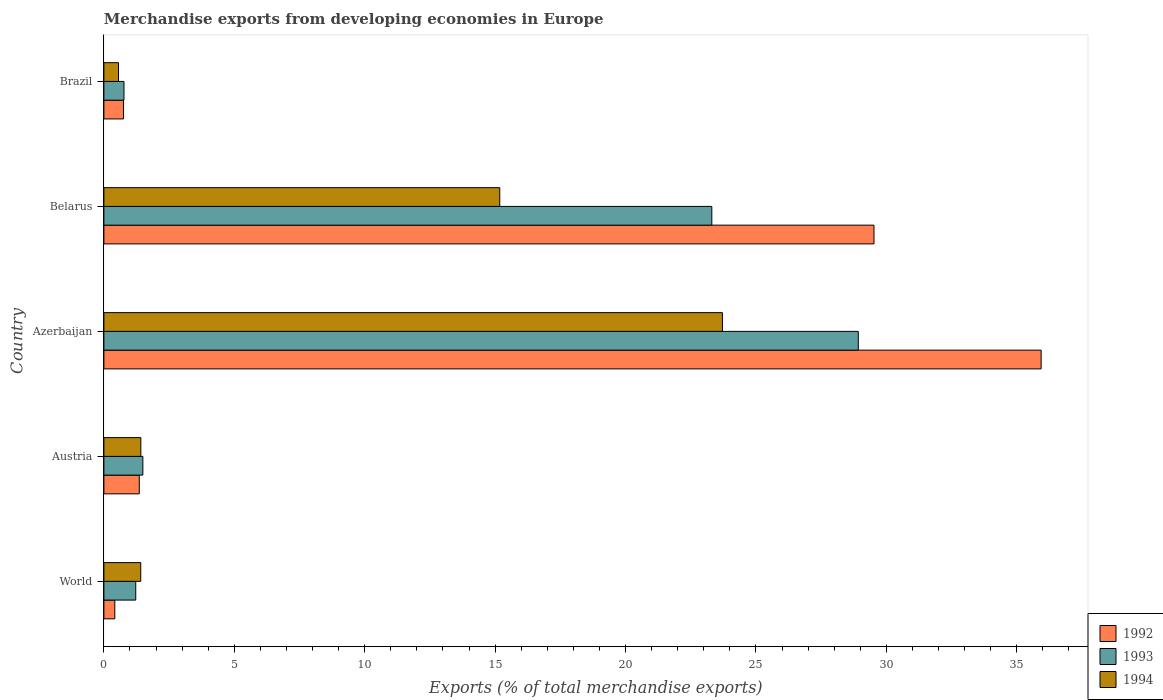How many different coloured bars are there?
Your response must be concise. 3. How many groups of bars are there?
Provide a succinct answer. 5. Are the number of bars on each tick of the Y-axis equal?
Give a very brief answer. Yes. How many bars are there on the 3rd tick from the bottom?
Offer a terse response. 3. What is the label of the 3rd group of bars from the top?
Give a very brief answer. Azerbaijan. What is the percentage of total merchandise exports in 1994 in Brazil?
Keep it short and to the point. 0.56. Across all countries, what is the maximum percentage of total merchandise exports in 1993?
Make the answer very short. 28.93. Across all countries, what is the minimum percentage of total merchandise exports in 1993?
Make the answer very short. 0.77. In which country was the percentage of total merchandise exports in 1993 maximum?
Ensure brevity in your answer.  Azerbaijan. What is the total percentage of total merchandise exports in 1994 in the graph?
Offer a very short reply. 42.29. What is the difference between the percentage of total merchandise exports in 1994 in Azerbaijan and that in Belarus?
Give a very brief answer. 8.54. What is the difference between the percentage of total merchandise exports in 1994 in Azerbaijan and the percentage of total merchandise exports in 1993 in Austria?
Offer a very short reply. 22.22. What is the average percentage of total merchandise exports in 1993 per country?
Make the answer very short. 11.14. What is the difference between the percentage of total merchandise exports in 1992 and percentage of total merchandise exports in 1993 in World?
Provide a succinct answer. -0.8. What is the ratio of the percentage of total merchandise exports in 1992 in Azerbaijan to that in Belarus?
Offer a terse response. 1.22. Is the percentage of total merchandise exports in 1993 in Brazil less than that in World?
Ensure brevity in your answer.  Yes. What is the difference between the highest and the second highest percentage of total merchandise exports in 1994?
Provide a succinct answer. 8.54. What is the difference between the highest and the lowest percentage of total merchandise exports in 1992?
Make the answer very short. 35.52. In how many countries, is the percentage of total merchandise exports in 1994 greater than the average percentage of total merchandise exports in 1994 taken over all countries?
Your answer should be compact. 2. What does the 2nd bar from the bottom in Austria represents?
Offer a terse response. 1993. Are the values on the major ticks of X-axis written in scientific E-notation?
Give a very brief answer. No. Does the graph contain any zero values?
Your answer should be compact. No. How many legend labels are there?
Give a very brief answer. 3. What is the title of the graph?
Keep it short and to the point. Merchandise exports from developing economies in Europe. What is the label or title of the X-axis?
Give a very brief answer. Exports (% of total merchandise exports). What is the Exports (% of total merchandise exports) in 1992 in World?
Keep it short and to the point. 0.42. What is the Exports (% of total merchandise exports) of 1993 in World?
Make the answer very short. 1.22. What is the Exports (% of total merchandise exports) in 1994 in World?
Ensure brevity in your answer.  1.41. What is the Exports (% of total merchandise exports) of 1992 in Austria?
Provide a succinct answer. 1.36. What is the Exports (% of total merchandise exports) of 1993 in Austria?
Keep it short and to the point. 1.49. What is the Exports (% of total merchandise exports) of 1994 in Austria?
Your answer should be compact. 1.42. What is the Exports (% of total merchandise exports) in 1992 in Azerbaijan?
Offer a terse response. 35.94. What is the Exports (% of total merchandise exports) in 1993 in Azerbaijan?
Make the answer very short. 28.93. What is the Exports (% of total merchandise exports) in 1994 in Azerbaijan?
Offer a terse response. 23.72. What is the Exports (% of total merchandise exports) in 1992 in Belarus?
Keep it short and to the point. 29.53. What is the Exports (% of total merchandise exports) of 1993 in Belarus?
Offer a terse response. 23.31. What is the Exports (% of total merchandise exports) in 1994 in Belarus?
Keep it short and to the point. 15.18. What is the Exports (% of total merchandise exports) in 1992 in Brazil?
Offer a terse response. 0.75. What is the Exports (% of total merchandise exports) in 1993 in Brazil?
Give a very brief answer. 0.77. What is the Exports (% of total merchandise exports) in 1994 in Brazil?
Make the answer very short. 0.56. Across all countries, what is the maximum Exports (% of total merchandise exports) of 1992?
Give a very brief answer. 35.94. Across all countries, what is the maximum Exports (% of total merchandise exports) of 1993?
Your response must be concise. 28.93. Across all countries, what is the maximum Exports (% of total merchandise exports) of 1994?
Ensure brevity in your answer.  23.72. Across all countries, what is the minimum Exports (% of total merchandise exports) in 1992?
Give a very brief answer. 0.42. Across all countries, what is the minimum Exports (% of total merchandise exports) in 1993?
Give a very brief answer. 0.77. Across all countries, what is the minimum Exports (% of total merchandise exports) in 1994?
Provide a succinct answer. 0.56. What is the total Exports (% of total merchandise exports) of 1992 in the graph?
Your answer should be compact. 67.99. What is the total Exports (% of total merchandise exports) in 1993 in the graph?
Provide a short and direct response. 55.72. What is the total Exports (% of total merchandise exports) of 1994 in the graph?
Your response must be concise. 42.29. What is the difference between the Exports (% of total merchandise exports) in 1992 in World and that in Austria?
Keep it short and to the point. -0.94. What is the difference between the Exports (% of total merchandise exports) of 1993 in World and that in Austria?
Your answer should be very brief. -0.27. What is the difference between the Exports (% of total merchandise exports) in 1994 in World and that in Austria?
Offer a very short reply. -0. What is the difference between the Exports (% of total merchandise exports) in 1992 in World and that in Azerbaijan?
Offer a very short reply. -35.52. What is the difference between the Exports (% of total merchandise exports) in 1993 in World and that in Azerbaijan?
Ensure brevity in your answer.  -27.7. What is the difference between the Exports (% of total merchandise exports) in 1994 in World and that in Azerbaijan?
Your response must be concise. -22.3. What is the difference between the Exports (% of total merchandise exports) in 1992 in World and that in Belarus?
Offer a very short reply. -29.11. What is the difference between the Exports (% of total merchandise exports) of 1993 in World and that in Belarus?
Make the answer very short. -22.09. What is the difference between the Exports (% of total merchandise exports) of 1994 in World and that in Belarus?
Give a very brief answer. -13.77. What is the difference between the Exports (% of total merchandise exports) in 1992 in World and that in Brazil?
Your response must be concise. -0.33. What is the difference between the Exports (% of total merchandise exports) of 1993 in World and that in Brazil?
Keep it short and to the point. 0.45. What is the difference between the Exports (% of total merchandise exports) of 1994 in World and that in Brazil?
Your answer should be very brief. 0.85. What is the difference between the Exports (% of total merchandise exports) of 1992 in Austria and that in Azerbaijan?
Your response must be concise. -34.58. What is the difference between the Exports (% of total merchandise exports) in 1993 in Austria and that in Azerbaijan?
Offer a very short reply. -27.43. What is the difference between the Exports (% of total merchandise exports) in 1994 in Austria and that in Azerbaijan?
Offer a terse response. -22.3. What is the difference between the Exports (% of total merchandise exports) in 1992 in Austria and that in Belarus?
Your answer should be very brief. -28.17. What is the difference between the Exports (% of total merchandise exports) of 1993 in Austria and that in Belarus?
Offer a terse response. -21.81. What is the difference between the Exports (% of total merchandise exports) in 1994 in Austria and that in Belarus?
Your answer should be compact. -13.76. What is the difference between the Exports (% of total merchandise exports) of 1992 in Austria and that in Brazil?
Keep it short and to the point. 0.6. What is the difference between the Exports (% of total merchandise exports) in 1993 in Austria and that in Brazil?
Give a very brief answer. 0.72. What is the difference between the Exports (% of total merchandise exports) of 1994 in Austria and that in Brazil?
Ensure brevity in your answer.  0.85. What is the difference between the Exports (% of total merchandise exports) of 1992 in Azerbaijan and that in Belarus?
Your answer should be very brief. 6.41. What is the difference between the Exports (% of total merchandise exports) of 1993 in Azerbaijan and that in Belarus?
Offer a very short reply. 5.62. What is the difference between the Exports (% of total merchandise exports) of 1994 in Azerbaijan and that in Belarus?
Your response must be concise. 8.54. What is the difference between the Exports (% of total merchandise exports) in 1992 in Azerbaijan and that in Brazil?
Provide a short and direct response. 35.18. What is the difference between the Exports (% of total merchandise exports) of 1993 in Azerbaijan and that in Brazil?
Your response must be concise. 28.16. What is the difference between the Exports (% of total merchandise exports) in 1994 in Azerbaijan and that in Brazil?
Make the answer very short. 23.15. What is the difference between the Exports (% of total merchandise exports) in 1992 in Belarus and that in Brazil?
Your answer should be very brief. 28.77. What is the difference between the Exports (% of total merchandise exports) in 1993 in Belarus and that in Brazil?
Your answer should be compact. 22.54. What is the difference between the Exports (% of total merchandise exports) of 1994 in Belarus and that in Brazil?
Make the answer very short. 14.62. What is the difference between the Exports (% of total merchandise exports) in 1992 in World and the Exports (% of total merchandise exports) in 1993 in Austria?
Your response must be concise. -1.08. What is the difference between the Exports (% of total merchandise exports) in 1992 in World and the Exports (% of total merchandise exports) in 1994 in Austria?
Provide a short and direct response. -1. What is the difference between the Exports (% of total merchandise exports) in 1993 in World and the Exports (% of total merchandise exports) in 1994 in Austria?
Ensure brevity in your answer.  -0.2. What is the difference between the Exports (% of total merchandise exports) in 1992 in World and the Exports (% of total merchandise exports) in 1993 in Azerbaijan?
Keep it short and to the point. -28.51. What is the difference between the Exports (% of total merchandise exports) in 1992 in World and the Exports (% of total merchandise exports) in 1994 in Azerbaijan?
Your answer should be very brief. -23.3. What is the difference between the Exports (% of total merchandise exports) in 1993 in World and the Exports (% of total merchandise exports) in 1994 in Azerbaijan?
Give a very brief answer. -22.49. What is the difference between the Exports (% of total merchandise exports) of 1992 in World and the Exports (% of total merchandise exports) of 1993 in Belarus?
Provide a succinct answer. -22.89. What is the difference between the Exports (% of total merchandise exports) of 1992 in World and the Exports (% of total merchandise exports) of 1994 in Belarus?
Offer a very short reply. -14.76. What is the difference between the Exports (% of total merchandise exports) in 1993 in World and the Exports (% of total merchandise exports) in 1994 in Belarus?
Offer a very short reply. -13.96. What is the difference between the Exports (% of total merchandise exports) of 1992 in World and the Exports (% of total merchandise exports) of 1993 in Brazil?
Your answer should be very brief. -0.35. What is the difference between the Exports (% of total merchandise exports) of 1992 in World and the Exports (% of total merchandise exports) of 1994 in Brazil?
Offer a terse response. -0.14. What is the difference between the Exports (% of total merchandise exports) of 1993 in World and the Exports (% of total merchandise exports) of 1994 in Brazil?
Offer a terse response. 0.66. What is the difference between the Exports (% of total merchandise exports) in 1992 in Austria and the Exports (% of total merchandise exports) in 1993 in Azerbaijan?
Offer a very short reply. -27.57. What is the difference between the Exports (% of total merchandise exports) in 1992 in Austria and the Exports (% of total merchandise exports) in 1994 in Azerbaijan?
Offer a very short reply. -22.36. What is the difference between the Exports (% of total merchandise exports) of 1993 in Austria and the Exports (% of total merchandise exports) of 1994 in Azerbaijan?
Ensure brevity in your answer.  -22.22. What is the difference between the Exports (% of total merchandise exports) of 1992 in Austria and the Exports (% of total merchandise exports) of 1993 in Belarus?
Your response must be concise. -21.95. What is the difference between the Exports (% of total merchandise exports) of 1992 in Austria and the Exports (% of total merchandise exports) of 1994 in Belarus?
Your answer should be very brief. -13.82. What is the difference between the Exports (% of total merchandise exports) in 1993 in Austria and the Exports (% of total merchandise exports) in 1994 in Belarus?
Provide a succinct answer. -13.68. What is the difference between the Exports (% of total merchandise exports) of 1992 in Austria and the Exports (% of total merchandise exports) of 1993 in Brazil?
Provide a succinct answer. 0.59. What is the difference between the Exports (% of total merchandise exports) of 1992 in Austria and the Exports (% of total merchandise exports) of 1994 in Brazil?
Give a very brief answer. 0.8. What is the difference between the Exports (% of total merchandise exports) of 1993 in Austria and the Exports (% of total merchandise exports) of 1994 in Brazil?
Ensure brevity in your answer.  0.93. What is the difference between the Exports (% of total merchandise exports) of 1992 in Azerbaijan and the Exports (% of total merchandise exports) of 1993 in Belarus?
Your response must be concise. 12.63. What is the difference between the Exports (% of total merchandise exports) in 1992 in Azerbaijan and the Exports (% of total merchandise exports) in 1994 in Belarus?
Provide a succinct answer. 20.76. What is the difference between the Exports (% of total merchandise exports) of 1993 in Azerbaijan and the Exports (% of total merchandise exports) of 1994 in Belarus?
Keep it short and to the point. 13.75. What is the difference between the Exports (% of total merchandise exports) in 1992 in Azerbaijan and the Exports (% of total merchandise exports) in 1993 in Brazil?
Your answer should be very brief. 35.17. What is the difference between the Exports (% of total merchandise exports) of 1992 in Azerbaijan and the Exports (% of total merchandise exports) of 1994 in Brazil?
Your answer should be compact. 35.37. What is the difference between the Exports (% of total merchandise exports) in 1993 in Azerbaijan and the Exports (% of total merchandise exports) in 1994 in Brazil?
Offer a very short reply. 28.36. What is the difference between the Exports (% of total merchandise exports) of 1992 in Belarus and the Exports (% of total merchandise exports) of 1993 in Brazil?
Your answer should be very brief. 28.76. What is the difference between the Exports (% of total merchandise exports) of 1992 in Belarus and the Exports (% of total merchandise exports) of 1994 in Brazil?
Provide a succinct answer. 28.97. What is the difference between the Exports (% of total merchandise exports) of 1993 in Belarus and the Exports (% of total merchandise exports) of 1994 in Brazil?
Provide a short and direct response. 22.75. What is the average Exports (% of total merchandise exports) in 1992 per country?
Ensure brevity in your answer.  13.6. What is the average Exports (% of total merchandise exports) of 1993 per country?
Ensure brevity in your answer.  11.14. What is the average Exports (% of total merchandise exports) of 1994 per country?
Ensure brevity in your answer.  8.46. What is the difference between the Exports (% of total merchandise exports) of 1992 and Exports (% of total merchandise exports) of 1993 in World?
Ensure brevity in your answer.  -0.8. What is the difference between the Exports (% of total merchandise exports) of 1992 and Exports (% of total merchandise exports) of 1994 in World?
Give a very brief answer. -0.99. What is the difference between the Exports (% of total merchandise exports) of 1993 and Exports (% of total merchandise exports) of 1994 in World?
Ensure brevity in your answer.  -0.19. What is the difference between the Exports (% of total merchandise exports) in 1992 and Exports (% of total merchandise exports) in 1993 in Austria?
Keep it short and to the point. -0.14. What is the difference between the Exports (% of total merchandise exports) of 1992 and Exports (% of total merchandise exports) of 1994 in Austria?
Make the answer very short. -0.06. What is the difference between the Exports (% of total merchandise exports) in 1993 and Exports (% of total merchandise exports) in 1994 in Austria?
Provide a succinct answer. 0.08. What is the difference between the Exports (% of total merchandise exports) of 1992 and Exports (% of total merchandise exports) of 1993 in Azerbaijan?
Your answer should be compact. 7.01. What is the difference between the Exports (% of total merchandise exports) of 1992 and Exports (% of total merchandise exports) of 1994 in Azerbaijan?
Give a very brief answer. 12.22. What is the difference between the Exports (% of total merchandise exports) of 1993 and Exports (% of total merchandise exports) of 1994 in Azerbaijan?
Provide a short and direct response. 5.21. What is the difference between the Exports (% of total merchandise exports) in 1992 and Exports (% of total merchandise exports) in 1993 in Belarus?
Your answer should be compact. 6.22. What is the difference between the Exports (% of total merchandise exports) of 1992 and Exports (% of total merchandise exports) of 1994 in Belarus?
Provide a short and direct response. 14.35. What is the difference between the Exports (% of total merchandise exports) of 1993 and Exports (% of total merchandise exports) of 1994 in Belarus?
Provide a short and direct response. 8.13. What is the difference between the Exports (% of total merchandise exports) of 1992 and Exports (% of total merchandise exports) of 1993 in Brazil?
Provide a short and direct response. -0.02. What is the difference between the Exports (% of total merchandise exports) of 1992 and Exports (% of total merchandise exports) of 1994 in Brazil?
Your answer should be compact. 0.19. What is the difference between the Exports (% of total merchandise exports) in 1993 and Exports (% of total merchandise exports) in 1994 in Brazil?
Provide a short and direct response. 0.21. What is the ratio of the Exports (% of total merchandise exports) of 1992 in World to that in Austria?
Provide a succinct answer. 0.31. What is the ratio of the Exports (% of total merchandise exports) in 1993 in World to that in Austria?
Make the answer very short. 0.82. What is the ratio of the Exports (% of total merchandise exports) of 1992 in World to that in Azerbaijan?
Provide a succinct answer. 0.01. What is the ratio of the Exports (% of total merchandise exports) in 1993 in World to that in Azerbaijan?
Provide a succinct answer. 0.04. What is the ratio of the Exports (% of total merchandise exports) in 1994 in World to that in Azerbaijan?
Offer a very short reply. 0.06. What is the ratio of the Exports (% of total merchandise exports) of 1992 in World to that in Belarus?
Ensure brevity in your answer.  0.01. What is the ratio of the Exports (% of total merchandise exports) in 1993 in World to that in Belarus?
Provide a short and direct response. 0.05. What is the ratio of the Exports (% of total merchandise exports) of 1994 in World to that in Belarus?
Your answer should be compact. 0.09. What is the ratio of the Exports (% of total merchandise exports) of 1992 in World to that in Brazil?
Your answer should be very brief. 0.56. What is the ratio of the Exports (% of total merchandise exports) of 1993 in World to that in Brazil?
Your response must be concise. 1.59. What is the ratio of the Exports (% of total merchandise exports) in 1994 in World to that in Brazil?
Your answer should be compact. 2.52. What is the ratio of the Exports (% of total merchandise exports) in 1992 in Austria to that in Azerbaijan?
Provide a succinct answer. 0.04. What is the ratio of the Exports (% of total merchandise exports) in 1993 in Austria to that in Azerbaijan?
Keep it short and to the point. 0.05. What is the ratio of the Exports (% of total merchandise exports) in 1994 in Austria to that in Azerbaijan?
Your answer should be compact. 0.06. What is the ratio of the Exports (% of total merchandise exports) in 1992 in Austria to that in Belarus?
Provide a succinct answer. 0.05. What is the ratio of the Exports (% of total merchandise exports) of 1993 in Austria to that in Belarus?
Your answer should be very brief. 0.06. What is the ratio of the Exports (% of total merchandise exports) of 1994 in Austria to that in Belarus?
Your answer should be compact. 0.09. What is the ratio of the Exports (% of total merchandise exports) in 1992 in Austria to that in Brazil?
Provide a succinct answer. 1.8. What is the ratio of the Exports (% of total merchandise exports) of 1993 in Austria to that in Brazil?
Keep it short and to the point. 1.94. What is the ratio of the Exports (% of total merchandise exports) in 1994 in Austria to that in Brazil?
Your answer should be compact. 2.52. What is the ratio of the Exports (% of total merchandise exports) in 1992 in Azerbaijan to that in Belarus?
Make the answer very short. 1.22. What is the ratio of the Exports (% of total merchandise exports) in 1993 in Azerbaijan to that in Belarus?
Ensure brevity in your answer.  1.24. What is the ratio of the Exports (% of total merchandise exports) in 1994 in Azerbaijan to that in Belarus?
Provide a succinct answer. 1.56. What is the ratio of the Exports (% of total merchandise exports) of 1992 in Azerbaijan to that in Brazil?
Give a very brief answer. 47.73. What is the ratio of the Exports (% of total merchandise exports) of 1993 in Azerbaijan to that in Brazil?
Your answer should be very brief. 37.55. What is the ratio of the Exports (% of total merchandise exports) of 1994 in Azerbaijan to that in Brazil?
Ensure brevity in your answer.  42.23. What is the ratio of the Exports (% of total merchandise exports) of 1992 in Belarus to that in Brazil?
Provide a succinct answer. 39.22. What is the ratio of the Exports (% of total merchandise exports) of 1993 in Belarus to that in Brazil?
Your answer should be very brief. 30.26. What is the ratio of the Exports (% of total merchandise exports) of 1994 in Belarus to that in Brazil?
Offer a very short reply. 27.03. What is the difference between the highest and the second highest Exports (% of total merchandise exports) in 1992?
Provide a short and direct response. 6.41. What is the difference between the highest and the second highest Exports (% of total merchandise exports) in 1993?
Make the answer very short. 5.62. What is the difference between the highest and the second highest Exports (% of total merchandise exports) in 1994?
Provide a short and direct response. 8.54. What is the difference between the highest and the lowest Exports (% of total merchandise exports) of 1992?
Your answer should be compact. 35.52. What is the difference between the highest and the lowest Exports (% of total merchandise exports) in 1993?
Give a very brief answer. 28.16. What is the difference between the highest and the lowest Exports (% of total merchandise exports) in 1994?
Your answer should be compact. 23.15. 